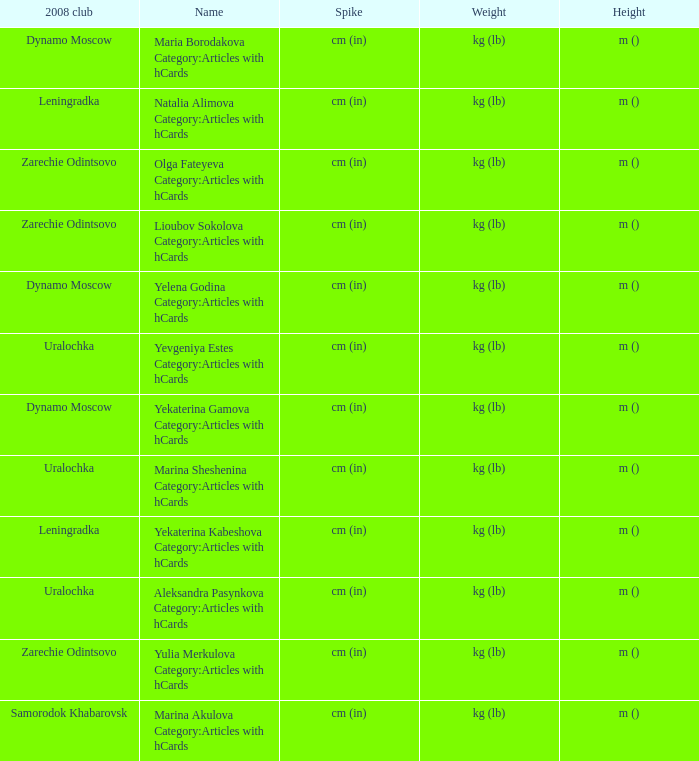What is the name when the 2008 club is uralochka? Yevgeniya Estes Category:Articles with hCards, Marina Sheshenina Category:Articles with hCards, Aleksandra Pasynkova Category:Articles with hCards. 